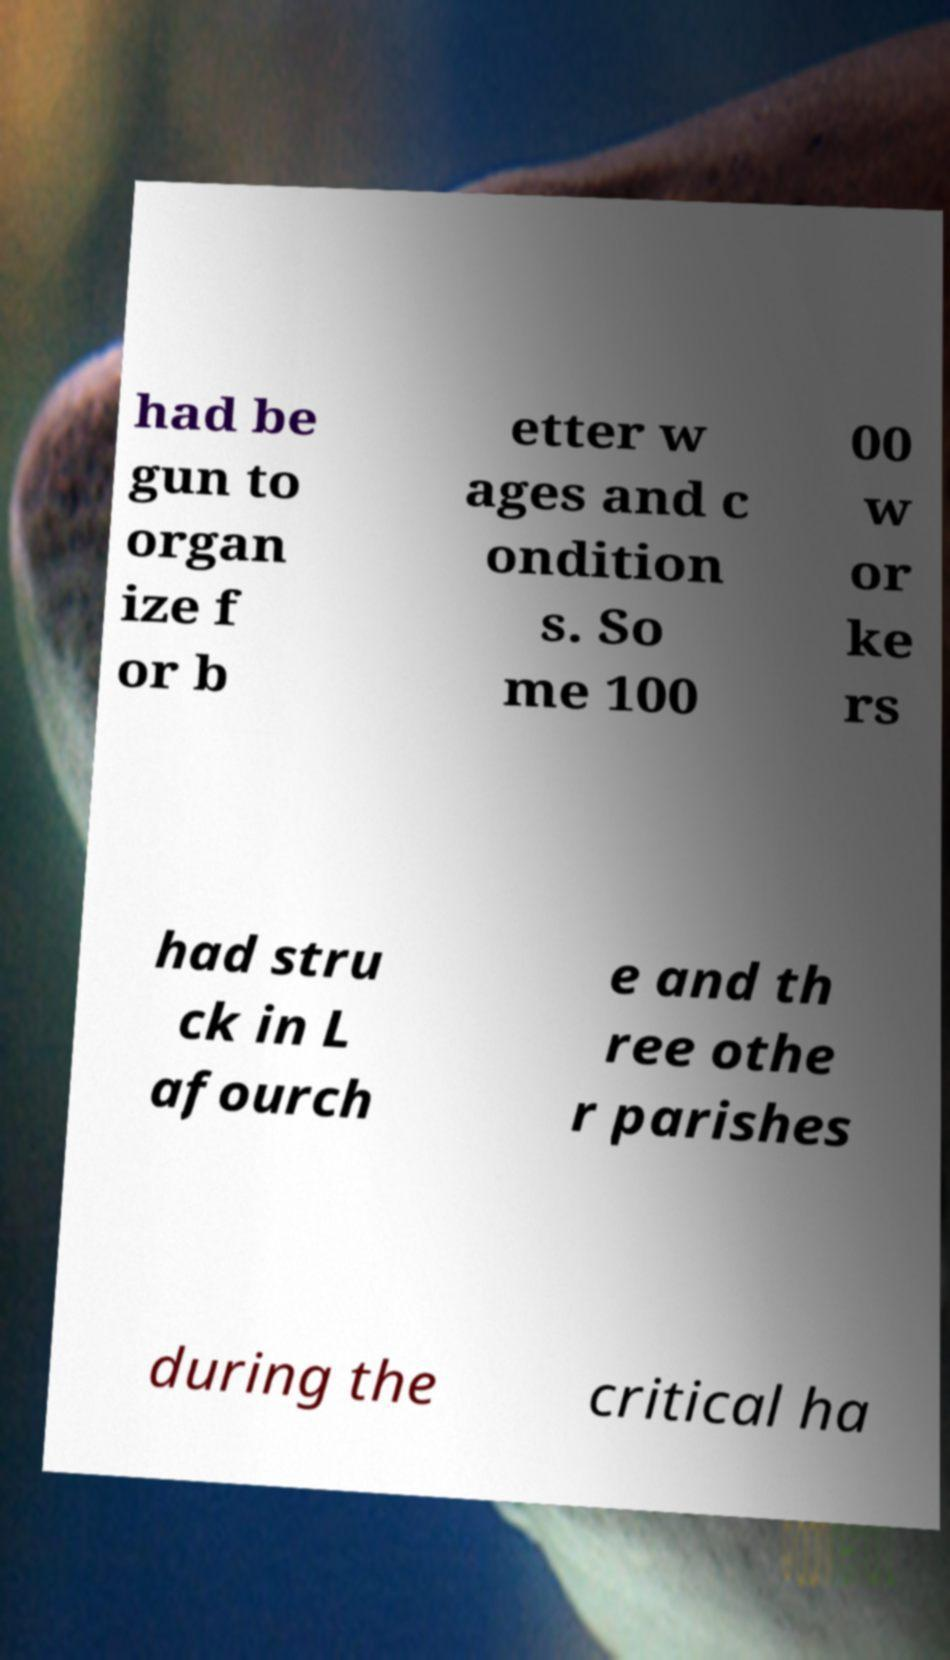I need the written content from this picture converted into text. Can you do that? had be gun to organ ize f or b etter w ages and c ondition s. So me 100 00 w or ke rs had stru ck in L afourch e and th ree othe r parishes during the critical ha 